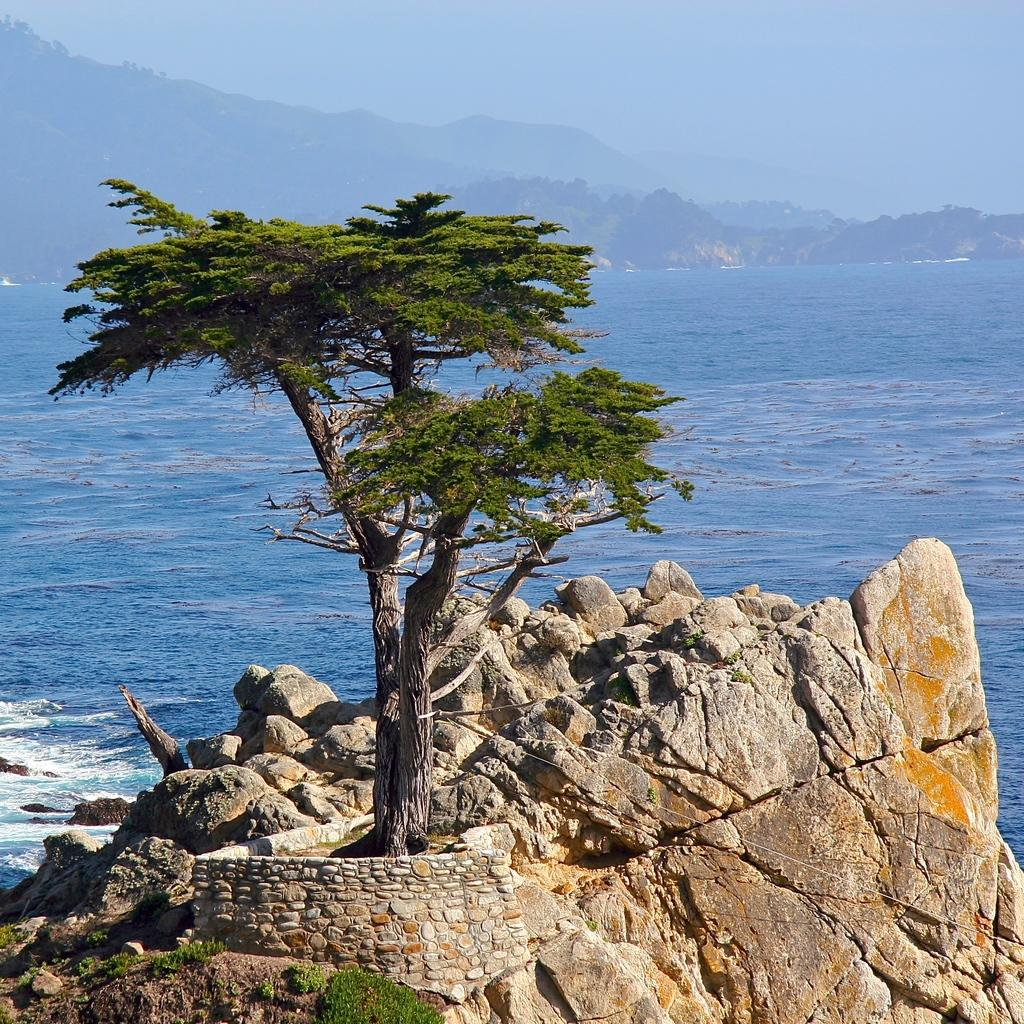What type of vegetation is present in the image? There is a tree in the image. What other natural elements can be seen in the image? There are rocks visible in the image. What can be seen in the distance in the image? There are mountains and water visible in the background of the image. What is visible above the mountains in the image? The sky is visible in the background of the image. How many children are shaking hands with the man in the image? There are no children or man present in the image. 